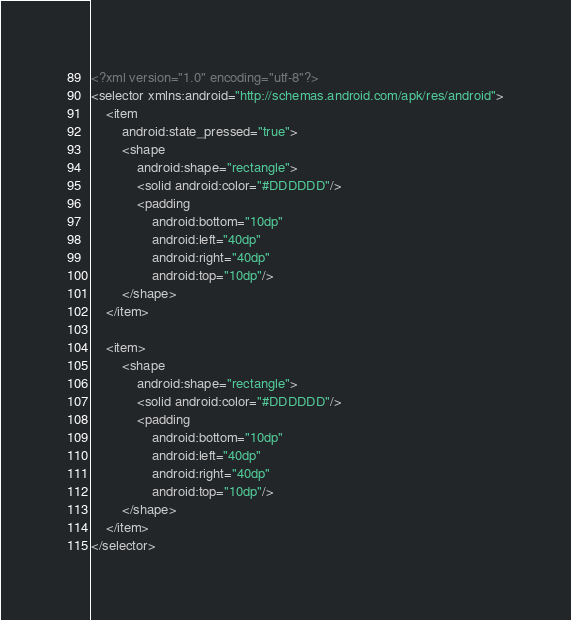<code> <loc_0><loc_0><loc_500><loc_500><_XML_><?xml version="1.0" encoding="utf-8"?>
<selector xmlns:android="http://schemas.android.com/apk/res/android">
    <item
        android:state_pressed="true">
        <shape
            android:shape="rectangle">
            <solid android:color="#DDDDDD"/>
            <padding
                android:bottom="10dp"
                android:left="40dp"
                android:right="40dp"
                android:top="10dp"/>
        </shape>
    </item>

    <item>
        <shape
            android:shape="rectangle">
            <solid android:color="#DDDDDD"/>
            <padding
                android:bottom="10dp"
                android:left="40dp"
                android:right="40dp"
                android:top="10dp"/>
        </shape>
    </item>
</selector></code> 